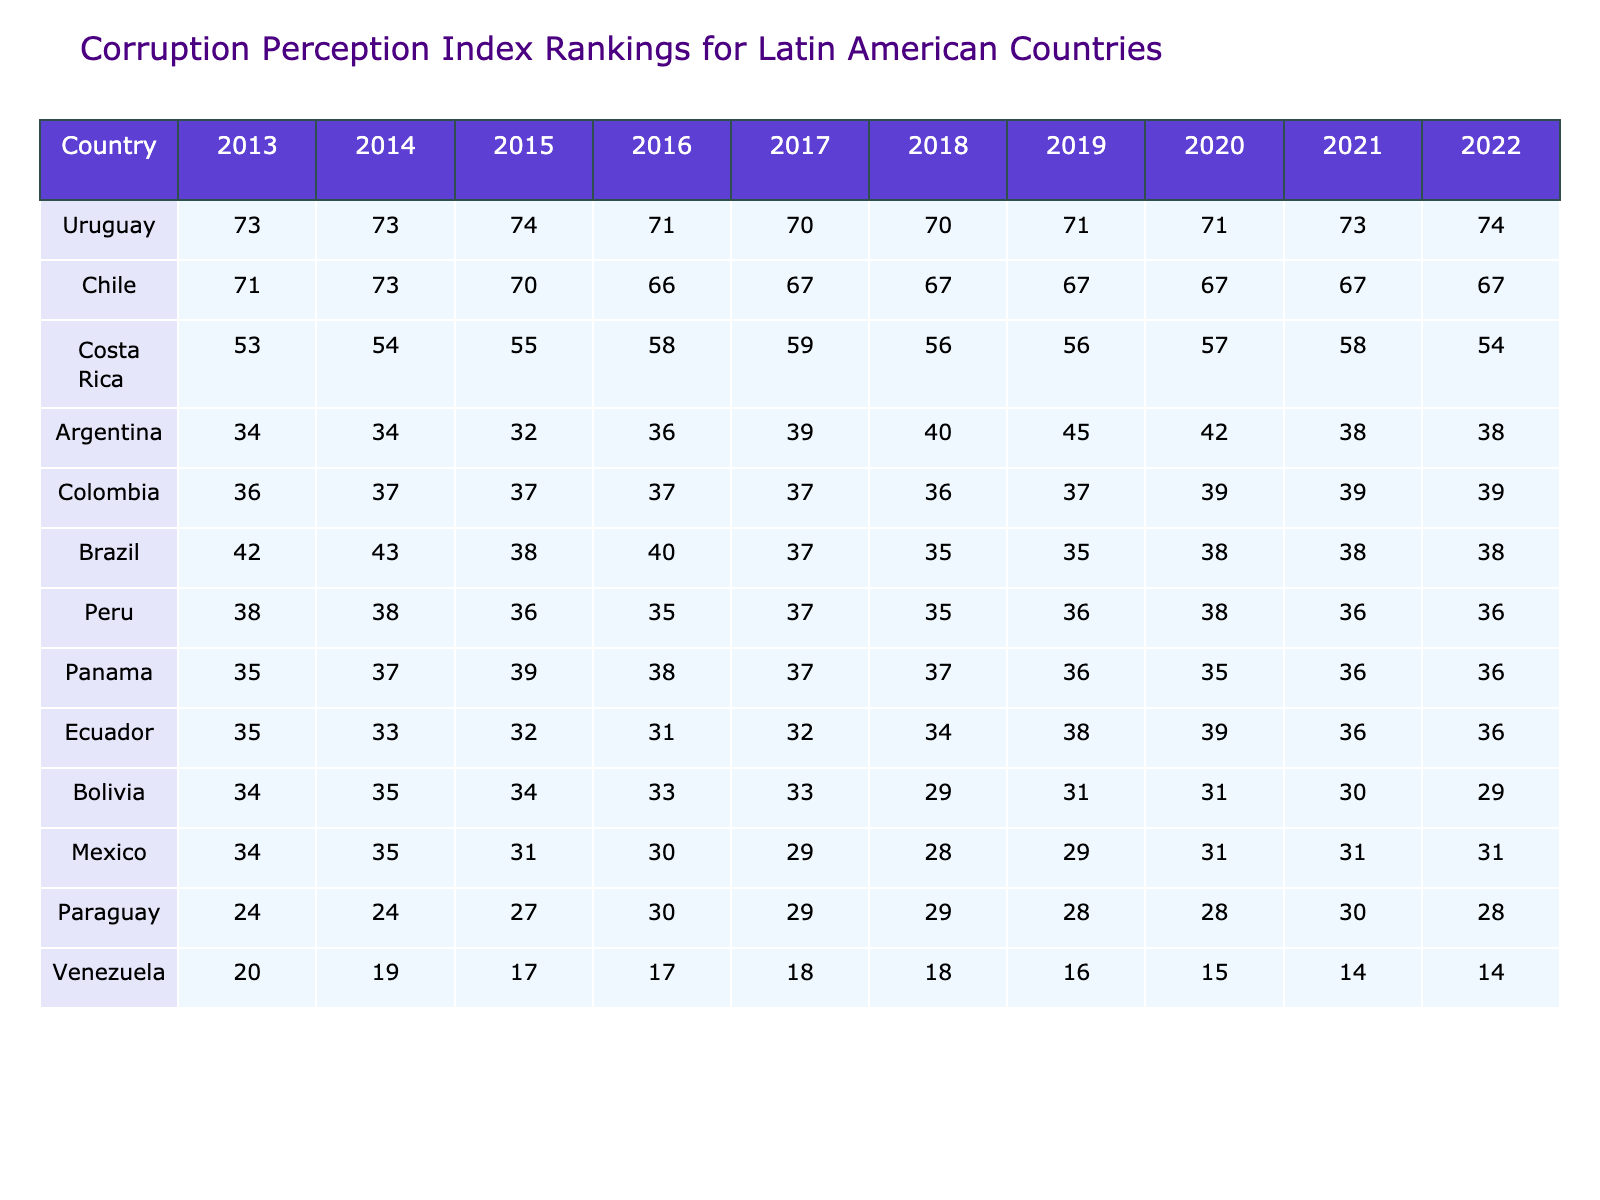What country had the highest Corruption Perception Index ranking in 2022? Referring to the last column (2022) in the table, Uruguay has the highest score with a value of 74.
Answer: Uruguay What was Argentina's Corruption Perception Index ranking in 2015? Looking at the row for Argentina, the value under the year 2015 is 32.
Answer: 32 Which country showed the most significant decline in its ranking from 2013 to 2022? Comparing the values from the first year (2013) to the last year (2022), Venezuela started at 20 and ended at 14, showing a decline of 6, which is the highest decline compared to other countries.
Answer: Venezuela What was the average Corruption Perception Index ranking for Uruguay over the last decade? Adding the values for Uruguay from 2013 to 2022: (73 + 73 + 74 + 71 + 70 + 70 + 71 + 71 + 73 + 74) = 724. Dividing by 10 gives an average of 72.4.
Answer: 72.4 Did any country maintain the same rank throughout the decade? Upon reviewing the data, Paraguay has a consistent score of 24 from 2013 to 2014, but it does not maintain the same rank throughout the entire decade, so the answer is no.
Answer: No What was the overall trend for Brazil from 2013 to 2022? Looking at the values for Brazil: 42, 43, 38, 40, 37, 35, 35, 38, 38, 38. It initially increased then fluctuated, but overall, the trend is a decline from 2013 to 2018, stabilizing around 38 afterwards.
Answer: Decline with stabilization Which country showed the most improvement in ranking from 2014 to 2019? Observing the values from 2014 to 2019, Argentina improved from 34 to 45, which is an increase of 11, the highest improvement compared to others.
Answer: Argentina What is the difference in ranking between Chile and Colombia in 2020? At 2020, Chile's score is 67 and Colombia's score is 39. The difference is calculated as 67 - 39 = 28.
Answer: 28 In what year did Ecuador have its lowest ranking? Looking at the values for Ecuador (35, 33, 32, 31, 32, 34, 38, 39, 36, 36), the lowest ranking of 31 occurred in 2016.
Answer: 2016 Is it true that Costa Rica's ranking decreased from 2013 to 2022? Checking the values for Costa Rica: 53, 54, 55, 58, 59, 56, 56, 57, 58, 54, it shows an increase until 2019, then a decrease. Hence, it is true overall from end to end.
Answer: True 